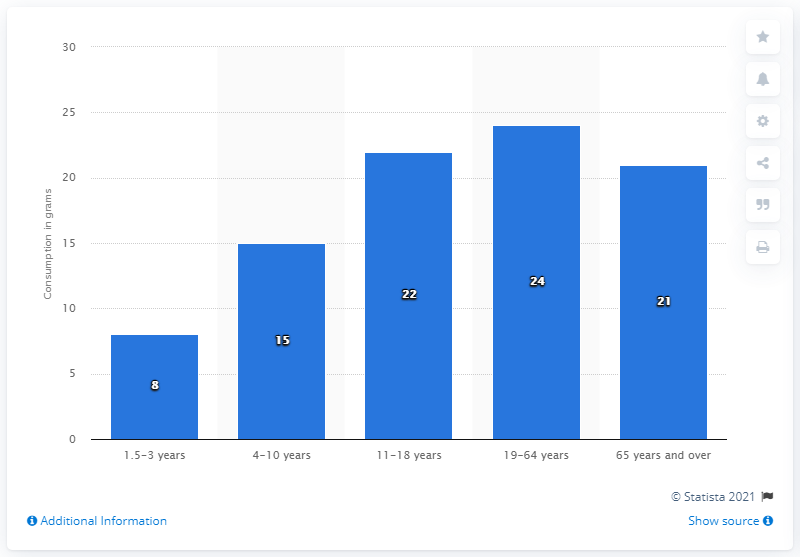Give some essential details in this illustration. Based on data collected between 2008 and 2012, the age group that consumed an average of 21 grams of sauces, pickles, gravies, and condiments per day was individuals aged 65 years and older. The age group of 65 years and over has seen a decrease compared to previous years. The median value for the category of 65 years and over is [21, 65 years and over]. 